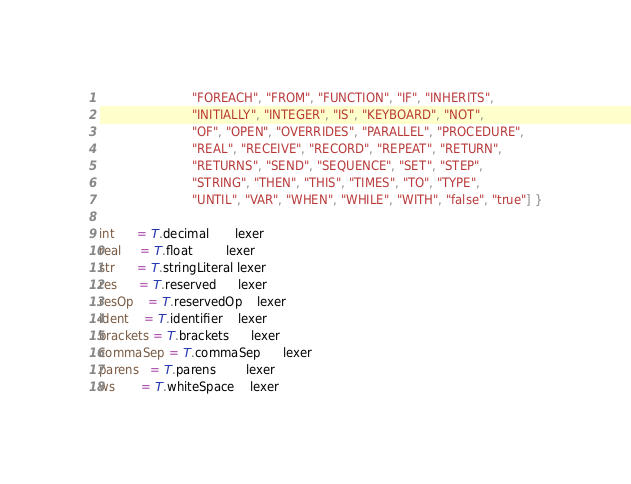<code> <loc_0><loc_0><loc_500><loc_500><_Haskell_>	                     "FOREACH", "FROM", "FUNCTION", "IF", "INHERITS",
	                     "INITIALLY", "INTEGER", "IS", "KEYBOARD", "NOT",
	                     "OF", "OPEN", "OVERRIDES", "PARALLEL", "PROCEDURE",
	                     "REAL", "RECEIVE", "RECORD", "REPEAT", "RETURN",
	                     "RETURNS", "SEND", "SEQUENCE", "SET", "STEP",
	                     "STRING", "THEN", "THIS", "TIMES", "TO", "TYPE",
	                     "UNTIL", "VAR", "WHEN", "WHILE", "WITH", "false", "true"] }

int      = T.decimal       lexer
real     = T.float         lexer
str      = T.stringLiteral lexer
res      = T.reserved      lexer
resOp    = T.reservedOp    lexer
ident    = T.identifier    lexer
brackets = T.brackets      lexer
commaSep = T.commaSep      lexer
parens   = T.parens        lexer
ws       = T.whiteSpace    lexer</code> 